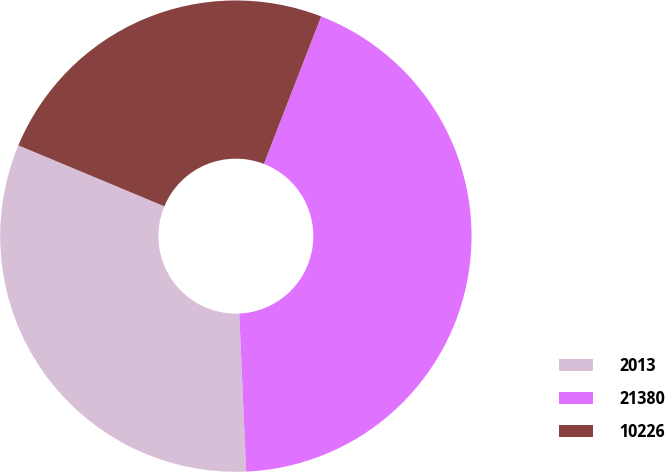Convert chart to OTSL. <chart><loc_0><loc_0><loc_500><loc_500><pie_chart><fcel>2013<fcel>21380<fcel>10226<nl><fcel>31.99%<fcel>43.41%<fcel>24.6%<nl></chart> 